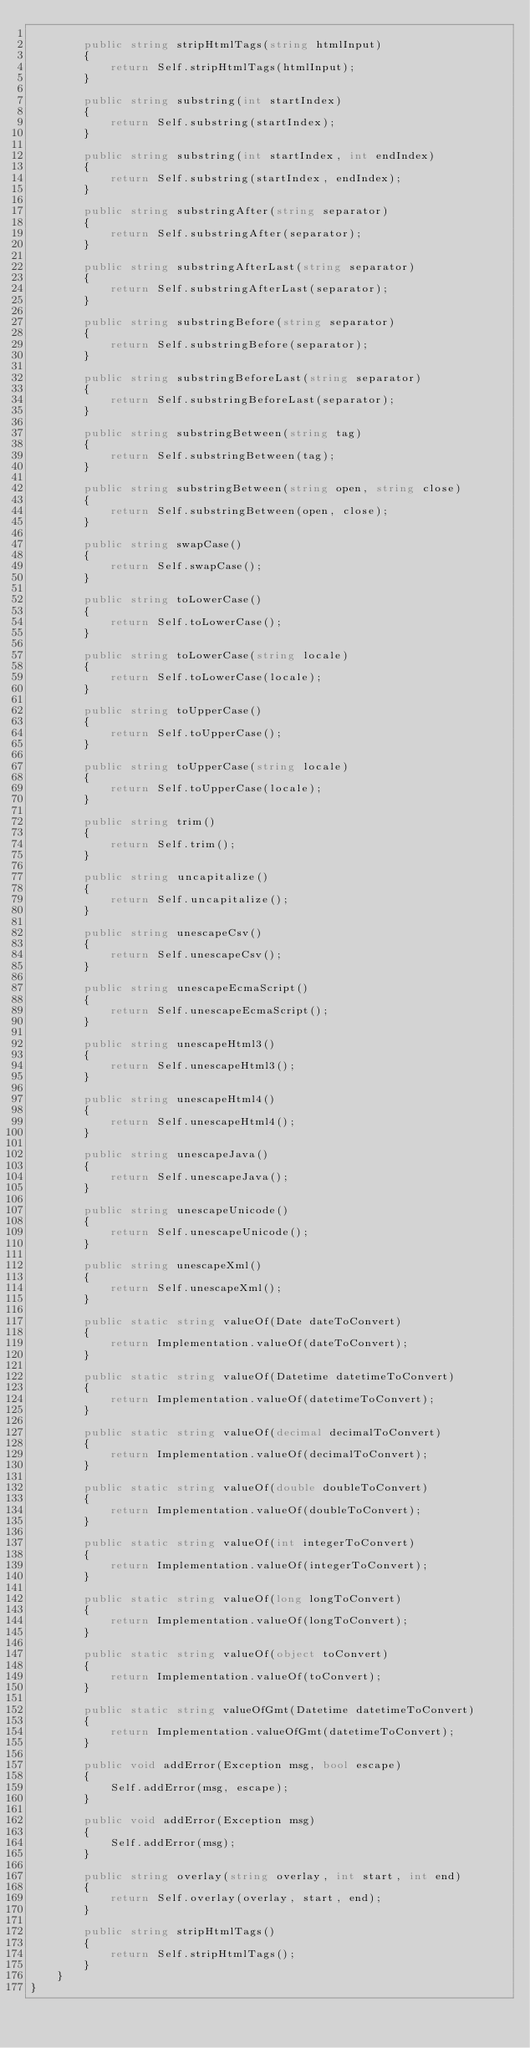<code> <loc_0><loc_0><loc_500><loc_500><_C#_>
        public string stripHtmlTags(string htmlInput)
        {
            return Self.stripHtmlTags(htmlInput);
        }

        public string substring(int startIndex)
        {
            return Self.substring(startIndex);
        }

        public string substring(int startIndex, int endIndex)
        {
            return Self.substring(startIndex, endIndex);
        }

        public string substringAfter(string separator)
        {
            return Self.substringAfter(separator);
        }

        public string substringAfterLast(string separator)
        {
            return Self.substringAfterLast(separator);
        }

        public string substringBefore(string separator)
        {
            return Self.substringBefore(separator);
        }

        public string substringBeforeLast(string separator)
        {
            return Self.substringBeforeLast(separator);
        }

        public string substringBetween(string tag)
        {
            return Self.substringBetween(tag);
        }

        public string substringBetween(string open, string close)
        {
            return Self.substringBetween(open, close);
        }

        public string swapCase()
        {
            return Self.swapCase();
        }

        public string toLowerCase()
        {
            return Self.toLowerCase();
        }

        public string toLowerCase(string locale)
        {
            return Self.toLowerCase(locale);
        }

        public string toUpperCase()
        {
            return Self.toUpperCase();
        }

        public string toUpperCase(string locale)
        {
            return Self.toUpperCase(locale);
        }

        public string trim()
        {
            return Self.trim();
        }

        public string uncapitalize()
        {
            return Self.uncapitalize();
        }

        public string unescapeCsv()
        {
            return Self.unescapeCsv();
        }

        public string unescapeEcmaScript()
        {
            return Self.unescapeEcmaScript();
        }

        public string unescapeHtml3()
        {
            return Self.unescapeHtml3();
        }

        public string unescapeHtml4()
        {
            return Self.unescapeHtml4();
        }

        public string unescapeJava()
        {
            return Self.unescapeJava();
        }

        public string unescapeUnicode()
        {
            return Self.unescapeUnicode();
        }

        public string unescapeXml()
        {
            return Self.unescapeXml();
        }

        public static string valueOf(Date dateToConvert)
        {
            return Implementation.valueOf(dateToConvert);
        }

        public static string valueOf(Datetime datetimeToConvert)
        {
            return Implementation.valueOf(datetimeToConvert);
        }

        public static string valueOf(decimal decimalToConvert)
        {
            return Implementation.valueOf(decimalToConvert);
        }

        public static string valueOf(double doubleToConvert)
        {
            return Implementation.valueOf(doubleToConvert);
        }

        public static string valueOf(int integerToConvert)
        {
            return Implementation.valueOf(integerToConvert);
        }

        public static string valueOf(long longToConvert)
        {
            return Implementation.valueOf(longToConvert);
        }

        public static string valueOf(object toConvert)
        {
            return Implementation.valueOf(toConvert);
        }

        public static string valueOfGmt(Datetime datetimeToConvert)
        {
            return Implementation.valueOfGmt(datetimeToConvert);
        }

        public void addError(Exception msg, bool escape)
        {
            Self.addError(msg, escape);
        }

        public void addError(Exception msg)
        {
            Self.addError(msg);
        }

        public string overlay(string overlay, int start, int end)
        {
            return Self.overlay(overlay, start, end);
        }

        public string stripHtmlTags()
        {
            return Self.stripHtmlTags();
        }
    }
}
</code> 